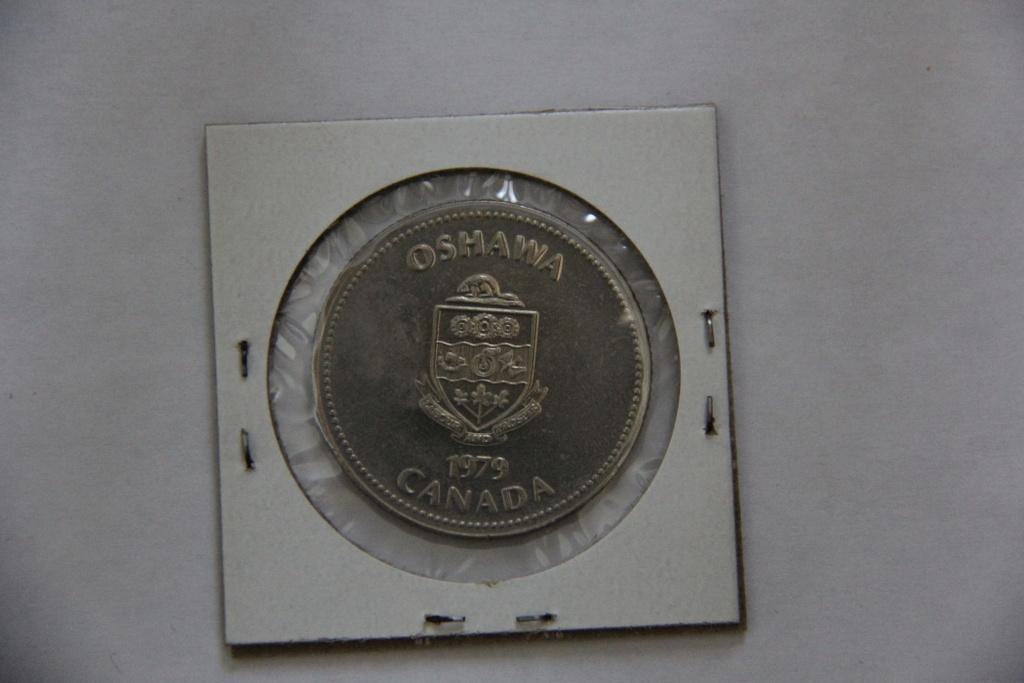<image>
Render a clear and concise summary of the photo. A coin stamped with Canada and 1979 is encased in plastic. 